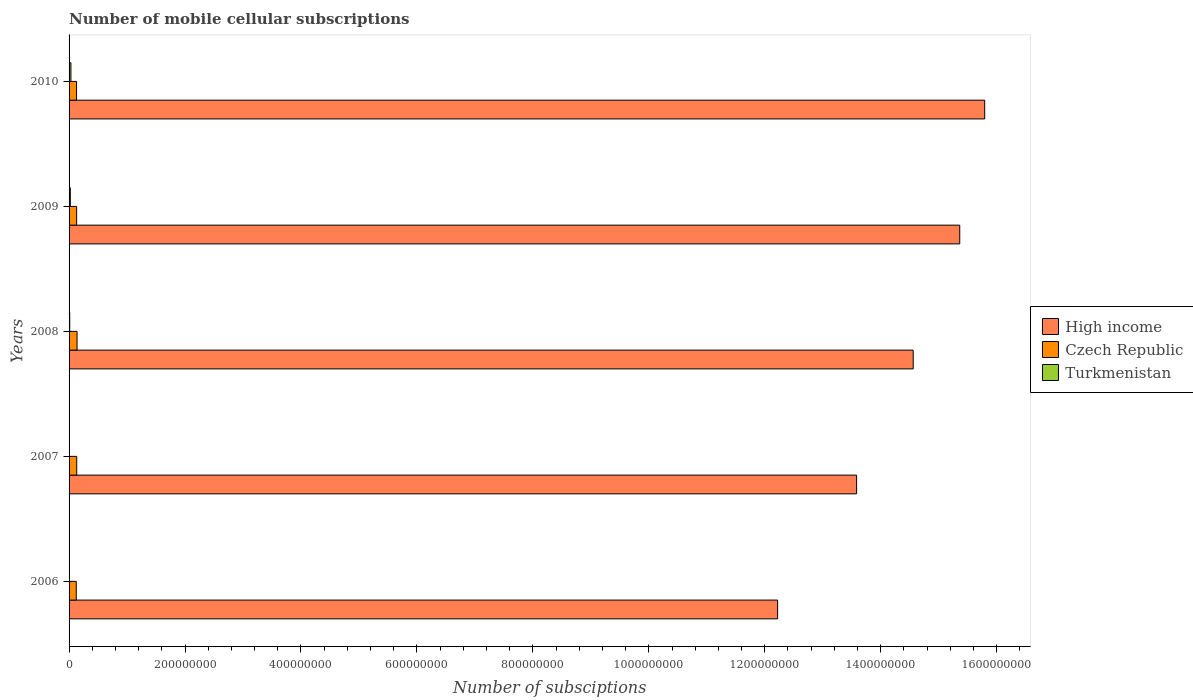How many groups of bars are there?
Give a very brief answer. 5. Are the number of bars per tick equal to the number of legend labels?
Make the answer very short. Yes. How many bars are there on the 1st tick from the top?
Provide a succinct answer. 3. What is the number of mobile cellular subscriptions in High income in 2010?
Offer a terse response. 1.58e+09. Across all years, what is the maximum number of mobile cellular subscriptions in High income?
Give a very brief answer. 1.58e+09. Across all years, what is the minimum number of mobile cellular subscriptions in Czech Republic?
Ensure brevity in your answer.  1.24e+07. In which year was the number of mobile cellular subscriptions in High income maximum?
Give a very brief answer. 2010. What is the total number of mobile cellular subscriptions in Czech Republic in the graph?
Make the answer very short. 6.54e+07. What is the difference between the number of mobile cellular subscriptions in Turkmenistan in 2007 and that in 2008?
Offer a terse response. -7.53e+05. What is the difference between the number of mobile cellular subscriptions in High income in 2010 and the number of mobile cellular subscriptions in Czech Republic in 2006?
Offer a terse response. 1.57e+09. What is the average number of mobile cellular subscriptions in High income per year?
Your response must be concise. 1.43e+09. In the year 2010, what is the difference between the number of mobile cellular subscriptions in Turkmenistan and number of mobile cellular subscriptions in Czech Republic?
Offer a terse response. -9.74e+06. What is the ratio of the number of mobile cellular subscriptions in High income in 2006 to that in 2010?
Your answer should be compact. 0.77. What is the difference between the highest and the second highest number of mobile cellular subscriptions in Czech Republic?
Provide a succinct answer. 5.52e+05. What is the difference between the highest and the lowest number of mobile cellular subscriptions in Turkmenistan?
Provide a short and direct response. 2.98e+06. In how many years, is the number of mobile cellular subscriptions in Turkmenistan greater than the average number of mobile cellular subscriptions in Turkmenistan taken over all years?
Ensure brevity in your answer.  2. Is the sum of the number of mobile cellular subscriptions in High income in 2007 and 2009 greater than the maximum number of mobile cellular subscriptions in Turkmenistan across all years?
Keep it short and to the point. Yes. What does the 3rd bar from the bottom in 2010 represents?
Give a very brief answer. Turkmenistan. How many years are there in the graph?
Your answer should be compact. 5. Are the values on the major ticks of X-axis written in scientific E-notation?
Provide a succinct answer. No. Does the graph contain any zero values?
Your response must be concise. No. Does the graph contain grids?
Give a very brief answer. No. Where does the legend appear in the graph?
Keep it short and to the point. Center right. How many legend labels are there?
Keep it short and to the point. 3. What is the title of the graph?
Your answer should be very brief. Number of mobile cellular subscriptions. What is the label or title of the X-axis?
Your response must be concise. Number of subsciptions. What is the label or title of the Y-axis?
Offer a terse response. Years. What is the Number of subsciptions in High income in 2006?
Your answer should be compact. 1.22e+09. What is the Number of subsciptions of Czech Republic in 2006?
Offer a very short reply. 1.24e+07. What is the Number of subsciptions in Turkmenistan in 2006?
Keep it short and to the point. 2.17e+05. What is the Number of subsciptions in High income in 2007?
Your answer should be compact. 1.36e+09. What is the Number of subsciptions of Czech Republic in 2007?
Your answer should be compact. 1.32e+07. What is the Number of subsciptions of Turkmenistan in 2007?
Provide a short and direct response. 3.82e+05. What is the Number of subsciptions of High income in 2008?
Provide a short and direct response. 1.46e+09. What is the Number of subsciptions of Czech Republic in 2008?
Offer a terse response. 1.38e+07. What is the Number of subsciptions in Turkmenistan in 2008?
Provide a short and direct response. 1.14e+06. What is the Number of subsciptions in High income in 2009?
Make the answer very short. 1.54e+09. What is the Number of subsciptions in Czech Republic in 2009?
Your response must be concise. 1.31e+07. What is the Number of subsciptions of Turkmenistan in 2009?
Provide a succinct answer. 2.13e+06. What is the Number of subsciptions of High income in 2010?
Your answer should be very brief. 1.58e+09. What is the Number of subsciptions in Czech Republic in 2010?
Your answer should be very brief. 1.29e+07. What is the Number of subsciptions of Turkmenistan in 2010?
Make the answer very short. 3.20e+06. Across all years, what is the maximum Number of subsciptions in High income?
Your response must be concise. 1.58e+09. Across all years, what is the maximum Number of subsciptions in Czech Republic?
Your answer should be compact. 1.38e+07. Across all years, what is the maximum Number of subsciptions of Turkmenistan?
Offer a terse response. 3.20e+06. Across all years, what is the minimum Number of subsciptions of High income?
Offer a very short reply. 1.22e+09. Across all years, what is the minimum Number of subsciptions in Czech Republic?
Provide a short and direct response. 1.24e+07. Across all years, what is the minimum Number of subsciptions in Turkmenistan?
Offer a terse response. 2.17e+05. What is the total Number of subsciptions of High income in the graph?
Offer a very short reply. 7.15e+09. What is the total Number of subsciptions of Czech Republic in the graph?
Give a very brief answer. 6.54e+07. What is the total Number of subsciptions in Turkmenistan in the graph?
Keep it short and to the point. 7.06e+06. What is the difference between the Number of subsciptions of High income in 2006 and that in 2007?
Make the answer very short. -1.36e+08. What is the difference between the Number of subsciptions of Czech Republic in 2006 and that in 2007?
Offer a very short reply. -8.22e+05. What is the difference between the Number of subsciptions of Turkmenistan in 2006 and that in 2007?
Offer a very short reply. -1.65e+05. What is the difference between the Number of subsciptions in High income in 2006 and that in 2008?
Offer a very short reply. -2.34e+08. What is the difference between the Number of subsciptions of Czech Republic in 2006 and that in 2008?
Ensure brevity in your answer.  -1.37e+06. What is the difference between the Number of subsciptions in Turkmenistan in 2006 and that in 2008?
Your response must be concise. -9.18e+05. What is the difference between the Number of subsciptions in High income in 2006 and that in 2009?
Ensure brevity in your answer.  -3.14e+08. What is the difference between the Number of subsciptions of Czech Republic in 2006 and that in 2009?
Provide a short and direct response. -6.56e+05. What is the difference between the Number of subsciptions in Turkmenistan in 2006 and that in 2009?
Your answer should be compact. -1.92e+06. What is the difference between the Number of subsciptions in High income in 2006 and that in 2010?
Ensure brevity in your answer.  -3.57e+08. What is the difference between the Number of subsciptions of Czech Republic in 2006 and that in 2010?
Your answer should be compact. -5.28e+05. What is the difference between the Number of subsciptions of Turkmenistan in 2006 and that in 2010?
Your answer should be very brief. -2.98e+06. What is the difference between the Number of subsciptions in High income in 2007 and that in 2008?
Your answer should be very brief. -9.76e+07. What is the difference between the Number of subsciptions in Czech Republic in 2007 and that in 2008?
Offer a very short reply. -5.52e+05. What is the difference between the Number of subsciptions in Turkmenistan in 2007 and that in 2008?
Your answer should be very brief. -7.53e+05. What is the difference between the Number of subsciptions of High income in 2007 and that in 2009?
Provide a succinct answer. -1.78e+08. What is the difference between the Number of subsciptions of Czech Republic in 2007 and that in 2009?
Keep it short and to the point. 1.66e+05. What is the difference between the Number of subsciptions in Turkmenistan in 2007 and that in 2009?
Offer a very short reply. -1.75e+06. What is the difference between the Number of subsciptions of High income in 2007 and that in 2010?
Provide a succinct answer. -2.21e+08. What is the difference between the Number of subsciptions of Czech Republic in 2007 and that in 2010?
Make the answer very short. 2.95e+05. What is the difference between the Number of subsciptions of Turkmenistan in 2007 and that in 2010?
Offer a terse response. -2.82e+06. What is the difference between the Number of subsciptions of High income in 2008 and that in 2009?
Your response must be concise. -8.03e+07. What is the difference between the Number of subsciptions in Czech Republic in 2008 and that in 2009?
Offer a very short reply. 7.18e+05. What is the difference between the Number of subsciptions in Turkmenistan in 2008 and that in 2009?
Give a very brief answer. -9.98e+05. What is the difference between the Number of subsciptions in High income in 2008 and that in 2010?
Your response must be concise. -1.23e+08. What is the difference between the Number of subsciptions of Czech Republic in 2008 and that in 2010?
Give a very brief answer. 8.46e+05. What is the difference between the Number of subsciptions of Turkmenistan in 2008 and that in 2010?
Provide a short and direct response. -2.06e+06. What is the difference between the Number of subsciptions of High income in 2009 and that in 2010?
Give a very brief answer. -4.30e+07. What is the difference between the Number of subsciptions in Czech Republic in 2009 and that in 2010?
Your response must be concise. 1.29e+05. What is the difference between the Number of subsciptions of Turkmenistan in 2009 and that in 2010?
Your answer should be very brief. -1.06e+06. What is the difference between the Number of subsciptions of High income in 2006 and the Number of subsciptions of Czech Republic in 2007?
Your answer should be very brief. 1.21e+09. What is the difference between the Number of subsciptions of High income in 2006 and the Number of subsciptions of Turkmenistan in 2007?
Your answer should be compact. 1.22e+09. What is the difference between the Number of subsciptions of Czech Republic in 2006 and the Number of subsciptions of Turkmenistan in 2007?
Your response must be concise. 1.20e+07. What is the difference between the Number of subsciptions in High income in 2006 and the Number of subsciptions in Czech Republic in 2008?
Your answer should be very brief. 1.21e+09. What is the difference between the Number of subsciptions in High income in 2006 and the Number of subsciptions in Turkmenistan in 2008?
Make the answer very short. 1.22e+09. What is the difference between the Number of subsciptions of Czech Republic in 2006 and the Number of subsciptions of Turkmenistan in 2008?
Provide a succinct answer. 1.13e+07. What is the difference between the Number of subsciptions in High income in 2006 and the Number of subsciptions in Czech Republic in 2009?
Your answer should be very brief. 1.21e+09. What is the difference between the Number of subsciptions in High income in 2006 and the Number of subsciptions in Turkmenistan in 2009?
Give a very brief answer. 1.22e+09. What is the difference between the Number of subsciptions in Czech Republic in 2006 and the Number of subsciptions in Turkmenistan in 2009?
Your answer should be very brief. 1.03e+07. What is the difference between the Number of subsciptions of High income in 2006 and the Number of subsciptions of Czech Republic in 2010?
Your answer should be compact. 1.21e+09. What is the difference between the Number of subsciptions of High income in 2006 and the Number of subsciptions of Turkmenistan in 2010?
Ensure brevity in your answer.  1.22e+09. What is the difference between the Number of subsciptions in Czech Republic in 2006 and the Number of subsciptions in Turkmenistan in 2010?
Your answer should be very brief. 9.21e+06. What is the difference between the Number of subsciptions in High income in 2007 and the Number of subsciptions in Czech Republic in 2008?
Ensure brevity in your answer.  1.34e+09. What is the difference between the Number of subsciptions of High income in 2007 and the Number of subsciptions of Turkmenistan in 2008?
Your response must be concise. 1.36e+09. What is the difference between the Number of subsciptions in Czech Republic in 2007 and the Number of subsciptions in Turkmenistan in 2008?
Your response must be concise. 1.21e+07. What is the difference between the Number of subsciptions of High income in 2007 and the Number of subsciptions of Czech Republic in 2009?
Keep it short and to the point. 1.35e+09. What is the difference between the Number of subsciptions of High income in 2007 and the Number of subsciptions of Turkmenistan in 2009?
Make the answer very short. 1.36e+09. What is the difference between the Number of subsciptions in Czech Republic in 2007 and the Number of subsciptions in Turkmenistan in 2009?
Make the answer very short. 1.11e+07. What is the difference between the Number of subsciptions of High income in 2007 and the Number of subsciptions of Czech Republic in 2010?
Ensure brevity in your answer.  1.35e+09. What is the difference between the Number of subsciptions of High income in 2007 and the Number of subsciptions of Turkmenistan in 2010?
Keep it short and to the point. 1.36e+09. What is the difference between the Number of subsciptions in Czech Republic in 2007 and the Number of subsciptions in Turkmenistan in 2010?
Ensure brevity in your answer.  1.00e+07. What is the difference between the Number of subsciptions in High income in 2008 and the Number of subsciptions in Czech Republic in 2009?
Your answer should be very brief. 1.44e+09. What is the difference between the Number of subsciptions in High income in 2008 and the Number of subsciptions in Turkmenistan in 2009?
Your response must be concise. 1.45e+09. What is the difference between the Number of subsciptions in Czech Republic in 2008 and the Number of subsciptions in Turkmenistan in 2009?
Give a very brief answer. 1.16e+07. What is the difference between the Number of subsciptions in High income in 2008 and the Number of subsciptions in Czech Republic in 2010?
Offer a terse response. 1.44e+09. What is the difference between the Number of subsciptions in High income in 2008 and the Number of subsciptions in Turkmenistan in 2010?
Provide a short and direct response. 1.45e+09. What is the difference between the Number of subsciptions of Czech Republic in 2008 and the Number of subsciptions of Turkmenistan in 2010?
Keep it short and to the point. 1.06e+07. What is the difference between the Number of subsciptions in High income in 2009 and the Number of subsciptions in Czech Republic in 2010?
Keep it short and to the point. 1.52e+09. What is the difference between the Number of subsciptions of High income in 2009 and the Number of subsciptions of Turkmenistan in 2010?
Your answer should be compact. 1.53e+09. What is the difference between the Number of subsciptions in Czech Republic in 2009 and the Number of subsciptions in Turkmenistan in 2010?
Offer a very short reply. 9.86e+06. What is the average Number of subsciptions of High income per year?
Your response must be concise. 1.43e+09. What is the average Number of subsciptions in Czech Republic per year?
Your answer should be compact. 1.31e+07. What is the average Number of subsciptions in Turkmenistan per year?
Your response must be concise. 1.41e+06. In the year 2006, what is the difference between the Number of subsciptions in High income and Number of subsciptions in Czech Republic?
Offer a terse response. 1.21e+09. In the year 2006, what is the difference between the Number of subsciptions in High income and Number of subsciptions in Turkmenistan?
Provide a succinct answer. 1.22e+09. In the year 2006, what is the difference between the Number of subsciptions of Czech Republic and Number of subsciptions of Turkmenistan?
Keep it short and to the point. 1.22e+07. In the year 2007, what is the difference between the Number of subsciptions of High income and Number of subsciptions of Czech Republic?
Provide a succinct answer. 1.35e+09. In the year 2007, what is the difference between the Number of subsciptions in High income and Number of subsciptions in Turkmenistan?
Your answer should be very brief. 1.36e+09. In the year 2007, what is the difference between the Number of subsciptions of Czech Republic and Number of subsciptions of Turkmenistan?
Provide a succinct answer. 1.28e+07. In the year 2008, what is the difference between the Number of subsciptions in High income and Number of subsciptions in Czech Republic?
Provide a succinct answer. 1.44e+09. In the year 2008, what is the difference between the Number of subsciptions of High income and Number of subsciptions of Turkmenistan?
Keep it short and to the point. 1.45e+09. In the year 2008, what is the difference between the Number of subsciptions of Czech Republic and Number of subsciptions of Turkmenistan?
Provide a short and direct response. 1.26e+07. In the year 2009, what is the difference between the Number of subsciptions in High income and Number of subsciptions in Czech Republic?
Make the answer very short. 1.52e+09. In the year 2009, what is the difference between the Number of subsciptions of High income and Number of subsciptions of Turkmenistan?
Give a very brief answer. 1.53e+09. In the year 2009, what is the difference between the Number of subsciptions of Czech Republic and Number of subsciptions of Turkmenistan?
Give a very brief answer. 1.09e+07. In the year 2010, what is the difference between the Number of subsciptions in High income and Number of subsciptions in Czech Republic?
Keep it short and to the point. 1.57e+09. In the year 2010, what is the difference between the Number of subsciptions of High income and Number of subsciptions of Turkmenistan?
Offer a very short reply. 1.58e+09. In the year 2010, what is the difference between the Number of subsciptions of Czech Republic and Number of subsciptions of Turkmenistan?
Ensure brevity in your answer.  9.74e+06. What is the ratio of the Number of subsciptions in High income in 2006 to that in 2007?
Your response must be concise. 0.9. What is the ratio of the Number of subsciptions of Czech Republic in 2006 to that in 2007?
Make the answer very short. 0.94. What is the ratio of the Number of subsciptions of Turkmenistan in 2006 to that in 2007?
Your answer should be compact. 0.57. What is the ratio of the Number of subsciptions in High income in 2006 to that in 2008?
Offer a terse response. 0.84. What is the ratio of the Number of subsciptions in Czech Republic in 2006 to that in 2008?
Make the answer very short. 0.9. What is the ratio of the Number of subsciptions of Turkmenistan in 2006 to that in 2008?
Give a very brief answer. 0.19. What is the ratio of the Number of subsciptions in High income in 2006 to that in 2009?
Provide a succinct answer. 0.8. What is the ratio of the Number of subsciptions in Czech Republic in 2006 to that in 2009?
Your response must be concise. 0.95. What is the ratio of the Number of subsciptions in Turkmenistan in 2006 to that in 2009?
Provide a short and direct response. 0.1. What is the ratio of the Number of subsciptions of High income in 2006 to that in 2010?
Ensure brevity in your answer.  0.77. What is the ratio of the Number of subsciptions in Czech Republic in 2006 to that in 2010?
Keep it short and to the point. 0.96. What is the ratio of the Number of subsciptions in Turkmenistan in 2006 to that in 2010?
Keep it short and to the point. 0.07. What is the ratio of the Number of subsciptions in High income in 2007 to that in 2008?
Your answer should be compact. 0.93. What is the ratio of the Number of subsciptions of Czech Republic in 2007 to that in 2008?
Give a very brief answer. 0.96. What is the ratio of the Number of subsciptions in Turkmenistan in 2007 to that in 2008?
Offer a terse response. 0.34. What is the ratio of the Number of subsciptions in High income in 2007 to that in 2009?
Give a very brief answer. 0.88. What is the ratio of the Number of subsciptions of Czech Republic in 2007 to that in 2009?
Your answer should be very brief. 1.01. What is the ratio of the Number of subsciptions of Turkmenistan in 2007 to that in 2009?
Provide a succinct answer. 0.18. What is the ratio of the Number of subsciptions of High income in 2007 to that in 2010?
Your answer should be very brief. 0.86. What is the ratio of the Number of subsciptions in Czech Republic in 2007 to that in 2010?
Keep it short and to the point. 1.02. What is the ratio of the Number of subsciptions of Turkmenistan in 2007 to that in 2010?
Provide a succinct answer. 0.12. What is the ratio of the Number of subsciptions in High income in 2008 to that in 2009?
Give a very brief answer. 0.95. What is the ratio of the Number of subsciptions in Czech Republic in 2008 to that in 2009?
Your answer should be compact. 1.05. What is the ratio of the Number of subsciptions of Turkmenistan in 2008 to that in 2009?
Offer a very short reply. 0.53. What is the ratio of the Number of subsciptions in High income in 2008 to that in 2010?
Provide a short and direct response. 0.92. What is the ratio of the Number of subsciptions of Czech Republic in 2008 to that in 2010?
Make the answer very short. 1.07. What is the ratio of the Number of subsciptions of Turkmenistan in 2008 to that in 2010?
Your answer should be very brief. 0.35. What is the ratio of the Number of subsciptions in High income in 2009 to that in 2010?
Provide a short and direct response. 0.97. What is the ratio of the Number of subsciptions in Czech Republic in 2009 to that in 2010?
Keep it short and to the point. 1.01. What is the ratio of the Number of subsciptions in Turkmenistan in 2009 to that in 2010?
Offer a very short reply. 0.67. What is the difference between the highest and the second highest Number of subsciptions of High income?
Provide a succinct answer. 4.30e+07. What is the difference between the highest and the second highest Number of subsciptions of Czech Republic?
Make the answer very short. 5.52e+05. What is the difference between the highest and the second highest Number of subsciptions of Turkmenistan?
Offer a very short reply. 1.06e+06. What is the difference between the highest and the lowest Number of subsciptions of High income?
Ensure brevity in your answer.  3.57e+08. What is the difference between the highest and the lowest Number of subsciptions in Czech Republic?
Your response must be concise. 1.37e+06. What is the difference between the highest and the lowest Number of subsciptions of Turkmenistan?
Your answer should be very brief. 2.98e+06. 